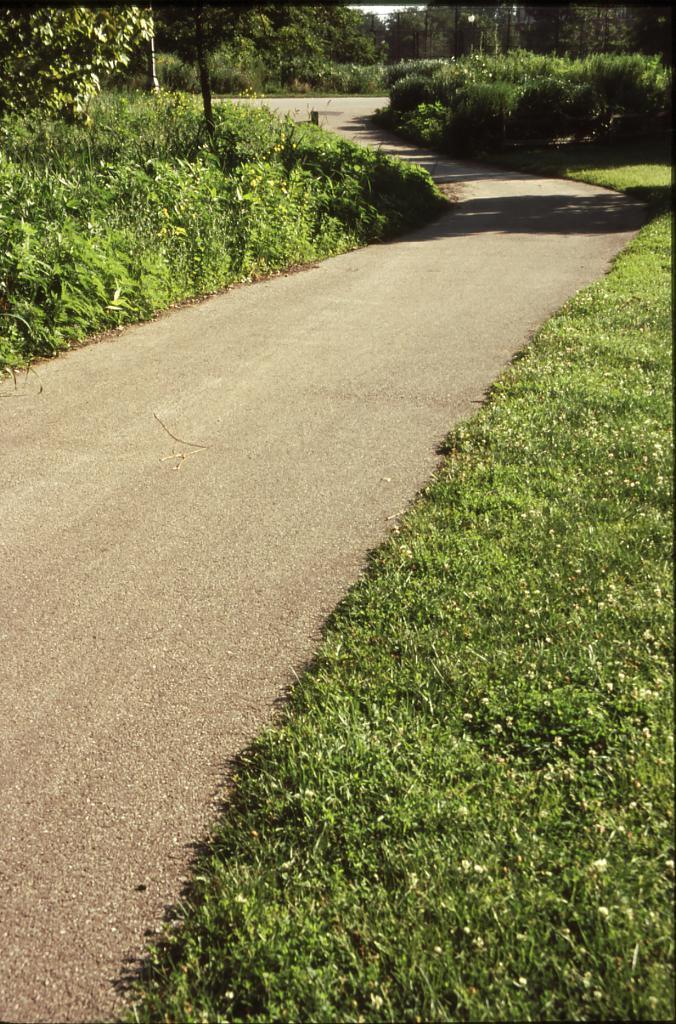How would you summarize this image in a sentence or two? This image is clicked on the road. On the either sides of the road there's grass on the ground. In the background there are trees and plants. There are poles in the image. 